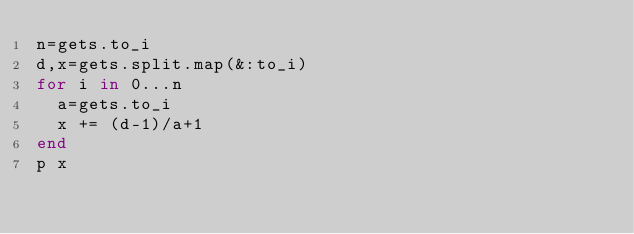<code> <loc_0><loc_0><loc_500><loc_500><_Ruby_>n=gets.to_i
d,x=gets.split.map(&:to_i)
for i in 0...n
  a=gets.to_i
  x += (d-1)/a+1
end
p x</code> 